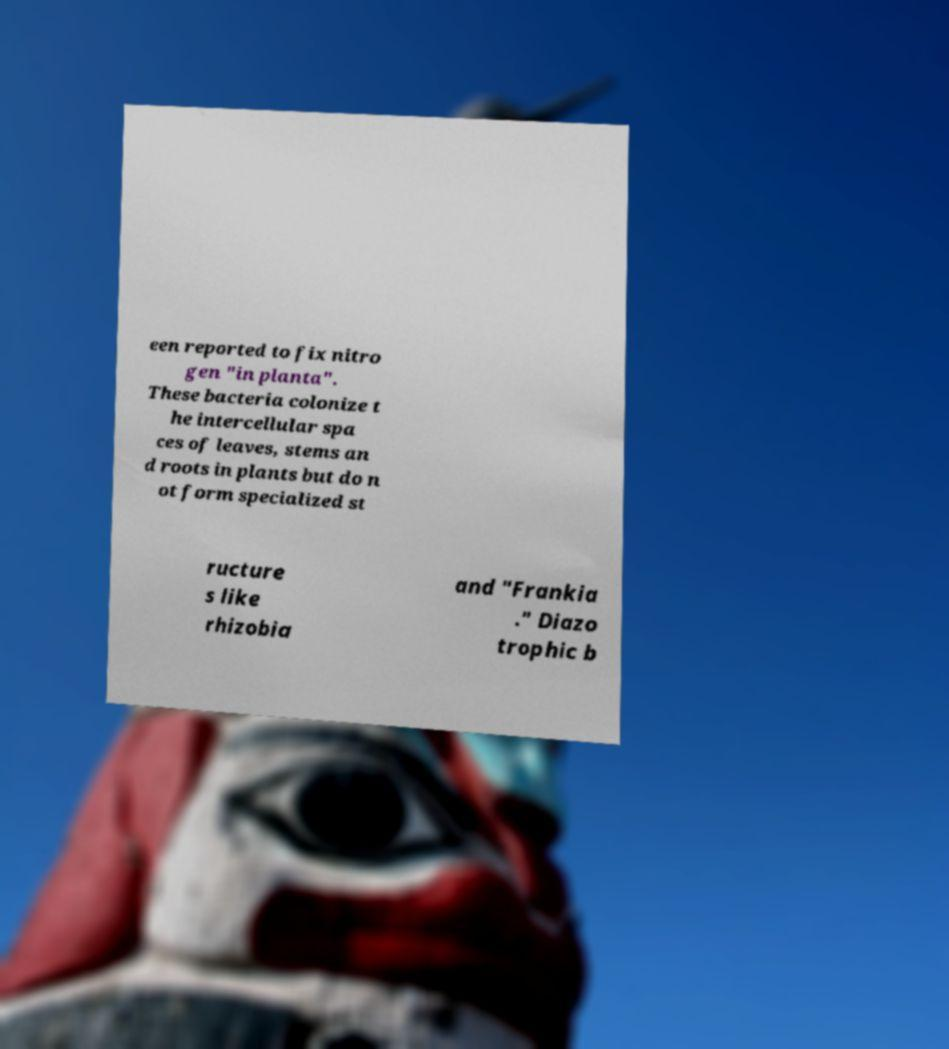Please identify and transcribe the text found in this image. een reported to fix nitro gen "in planta". These bacteria colonize t he intercellular spa ces of leaves, stems an d roots in plants but do n ot form specialized st ructure s like rhizobia and "Frankia ." Diazo trophic b 